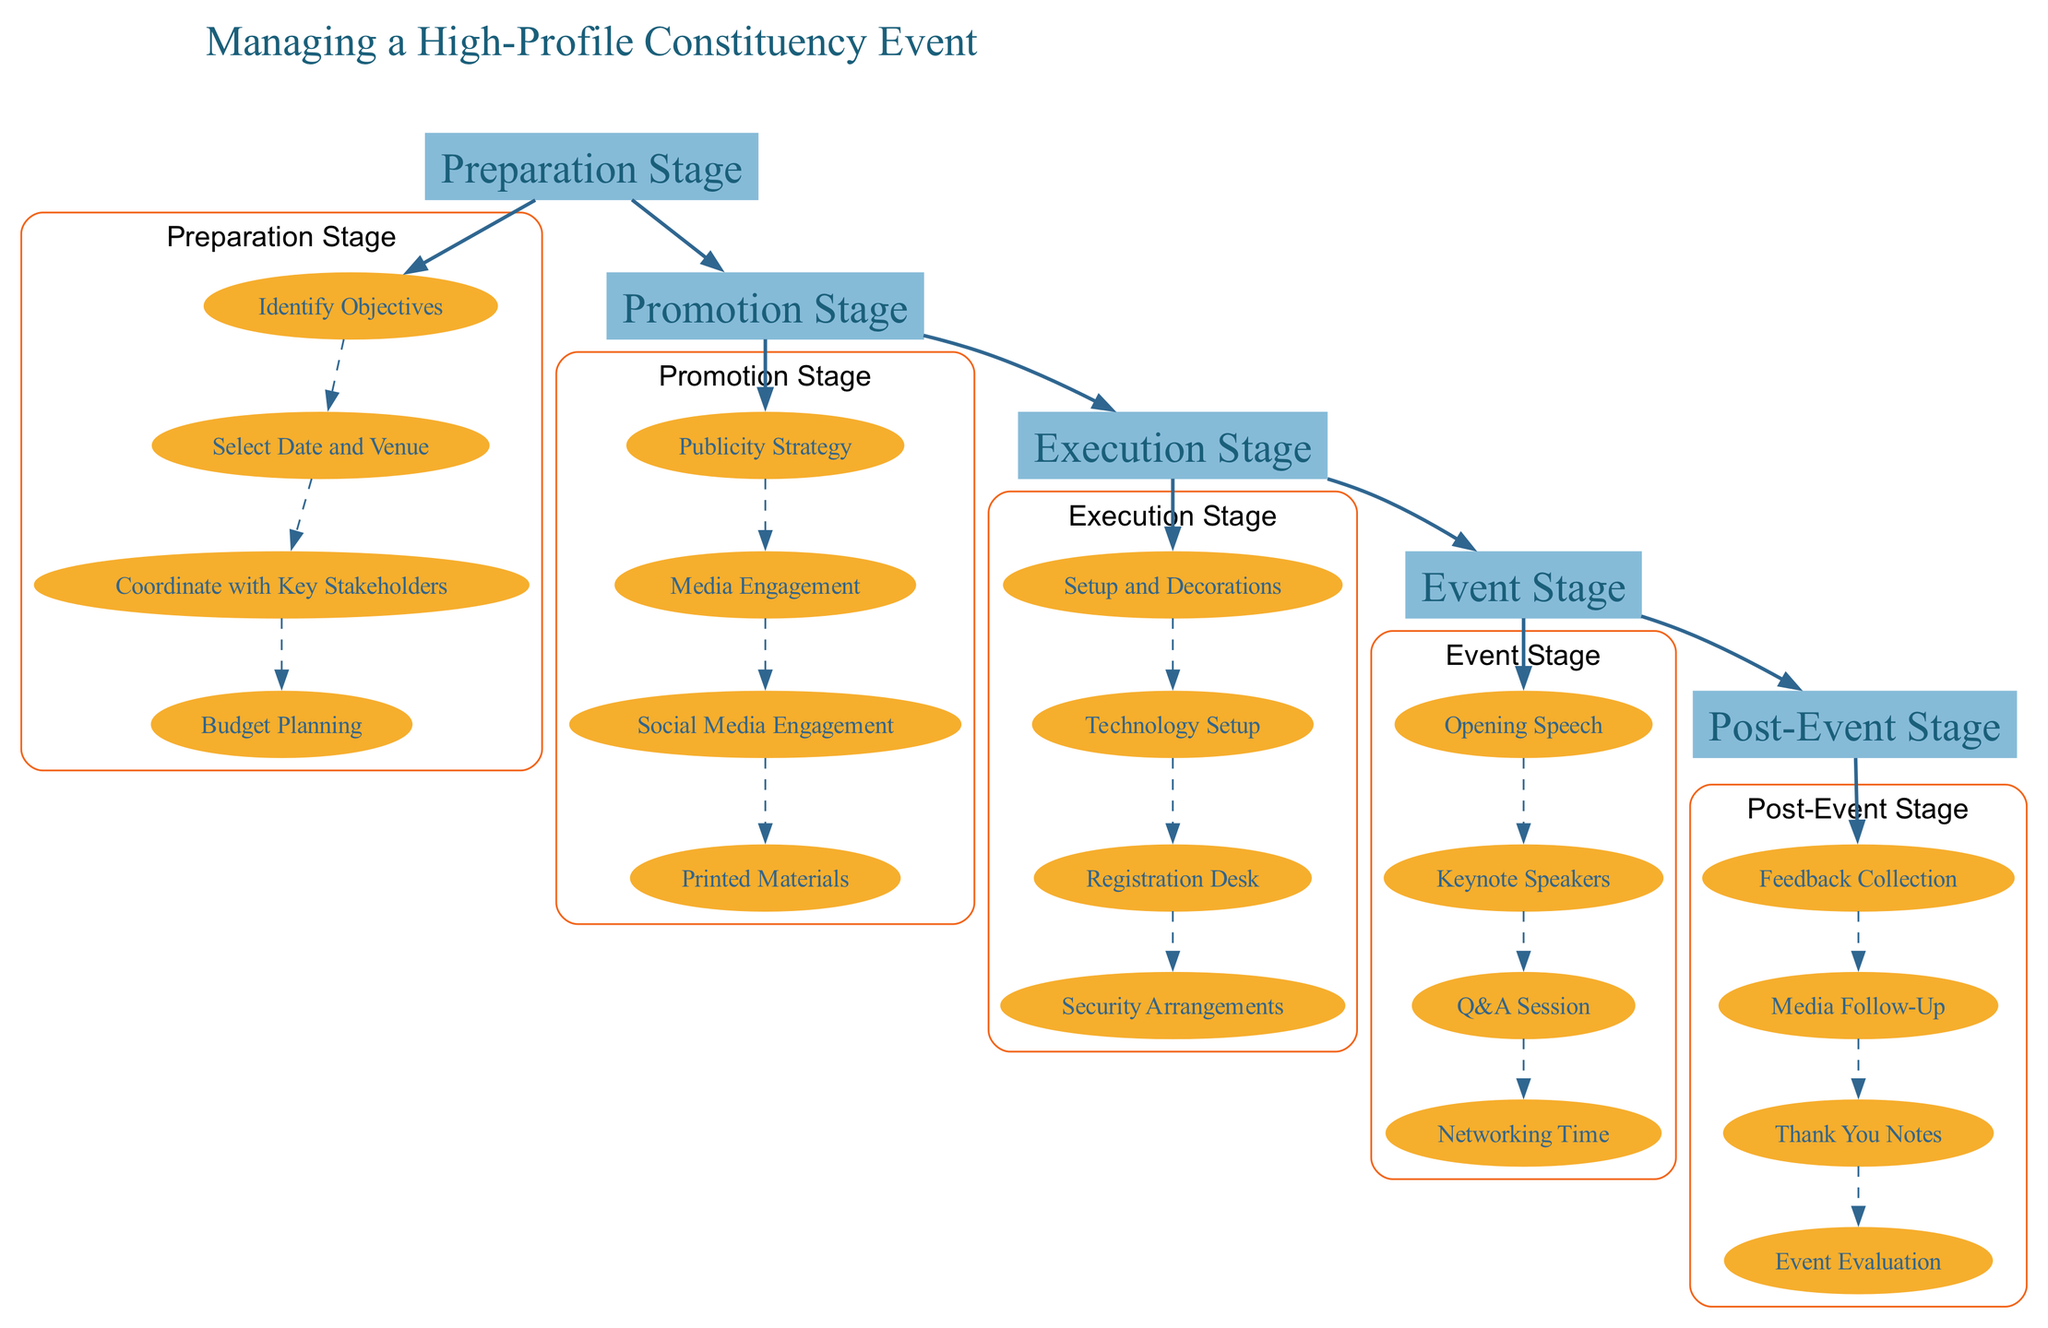What is the first stage in managing a high-profile constituency event? The diagram lists "Preparation Stage" as the first entry in the sequence of stages used to manage the event.
Answer: Preparation Stage How many tasks are listed under the "Execution Stage"? By examining the "Execution Stage," there are four specific tasks that are outlined: Setup and Decorations, Technology Setup, Registration Desk, and Security Arrangements, implying a total of four tasks.
Answer: 4 Which stage comes directly after the "Promotion Stage"? The flow of the diagram indicates that after the "Promotion Stage," the next sequential stage is the "Execution Stage," thus marking the transition in the workflow.
Answer: Execution Stage What is one task included in the "Post-Event Stage"? Within the "Post-Event Stage," multiple tasks are detailed; one example from these tasks is "Feedback Collection," which is a critical part of the event follow-up.
Answer: Feedback Collection How many total stages are there in the event management process? By counting, the diagram presents five distinct stages in the overall management process for the event, indicating a comprehensive flow from preparation to post-event activities.
Answer: 5 What task directly follows "Keynote Speakers" during the Event Stage? From the structure of the Event Stage, the task that follows after "Keynote Speakers" is "Q&A Session," as indicated by the sequential arrangement of tasks.
Answer: Q&A Session What type of materials are prepared during the Promotion Stage? The Promotion Stage describes the preparation of "Printed Materials," which includes posters, flyers, and banners needed for effective dissemination of event information.
Answer: Printed Materials Which two roles are crucial for the "Security Arrangements" task? In assembling the response, one must consider the community safety aspects highlighted in the diagram, where local law enforcement plays a crucial role in ensuring safety and crowd control.
Answer: Local law enforcement What is the purpose of the "Budget Planning" task? The "Budget Planning" task is essential for managing finances related to the event, as it ensures allocation of necessary funds across various expenses such as venue booking and catering.
Answer: Financial management 